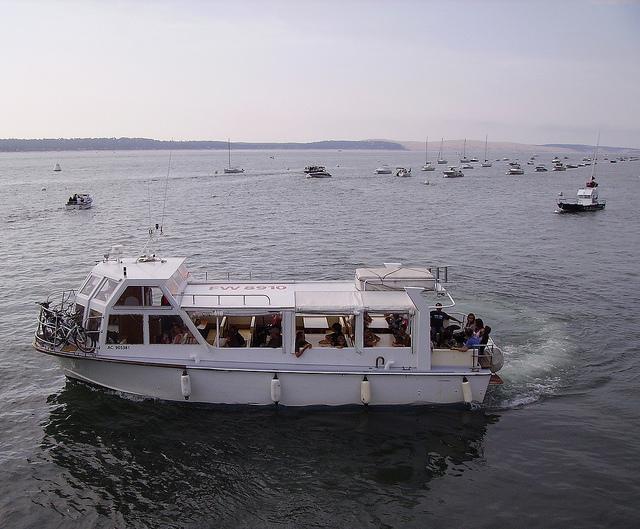What vehicle is stored in front of the boat?
Select the accurate answer and provide explanation: 'Answer: answer
Rationale: rationale.'
Options: Raft, quad, sedan, bike. Answer: bike.
Rationale: Bikes are crammed up front. 